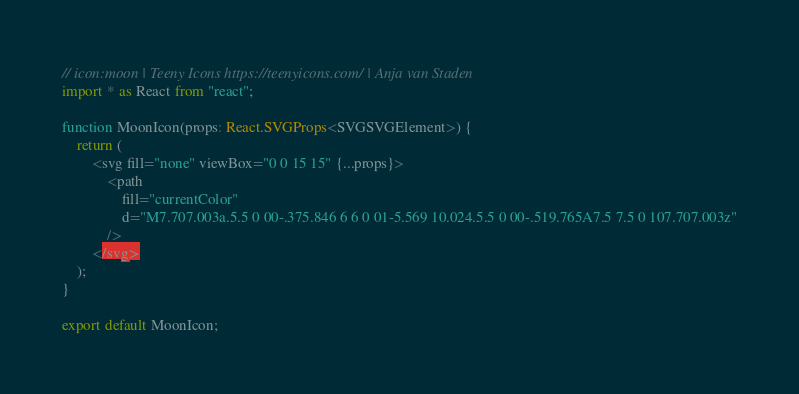Convert code to text. <code><loc_0><loc_0><loc_500><loc_500><_TypeScript_>// icon:moon | Teeny Icons https://teenyicons.com/ | Anja van Staden
import * as React from "react";

function MoonIcon(props: React.SVGProps<SVGSVGElement>) {
    return (
        <svg fill="none" viewBox="0 0 15 15" {...props}>
            <path
                fill="currentColor"
                d="M7.707.003a.5.5 0 00-.375.846 6 6 0 01-5.569 10.024.5.5 0 00-.519.765A7.5 7.5 0 107.707.003z"
            />
        </svg>
    );
}

export default MoonIcon;</code> 